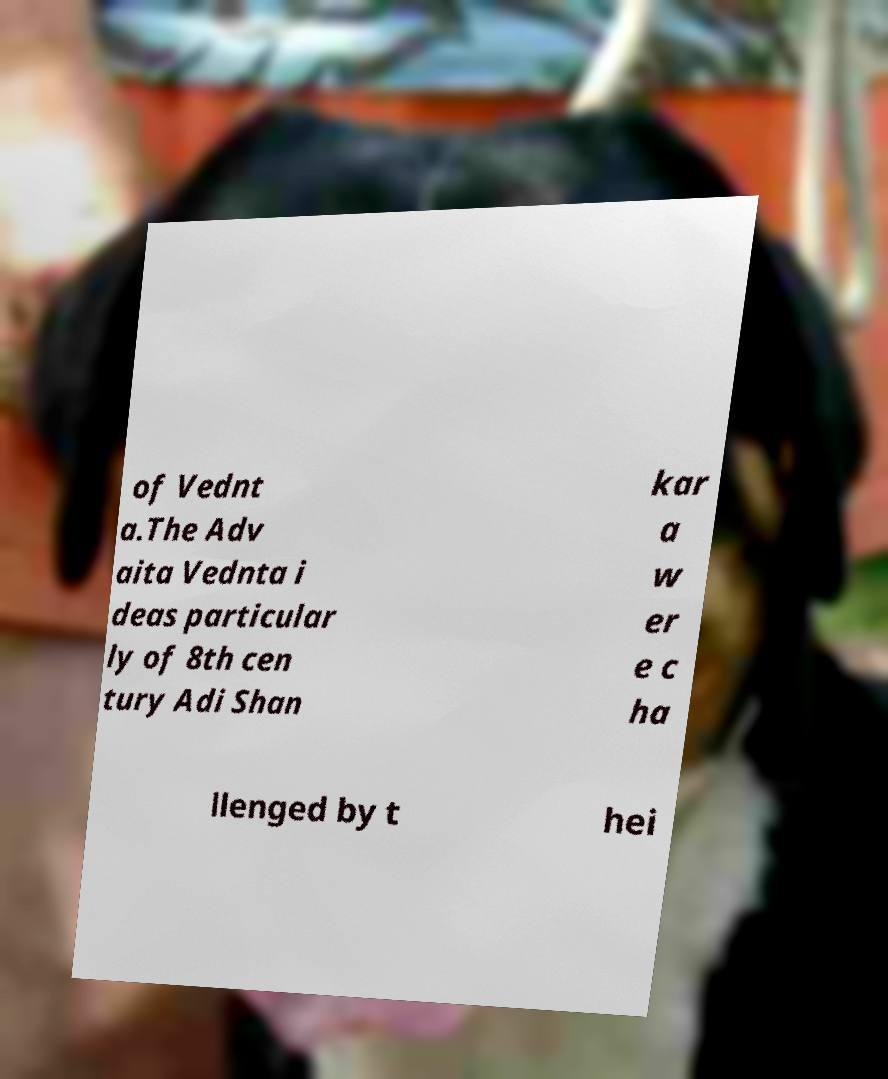Can you read and provide the text displayed in the image?This photo seems to have some interesting text. Can you extract and type it out for me? of Vednt a.The Adv aita Vednta i deas particular ly of 8th cen tury Adi Shan kar a w er e c ha llenged by t hei 